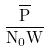<formula> <loc_0><loc_0><loc_500><loc_500>\frac { \overline { P } } { N _ { 0 } W }</formula> 